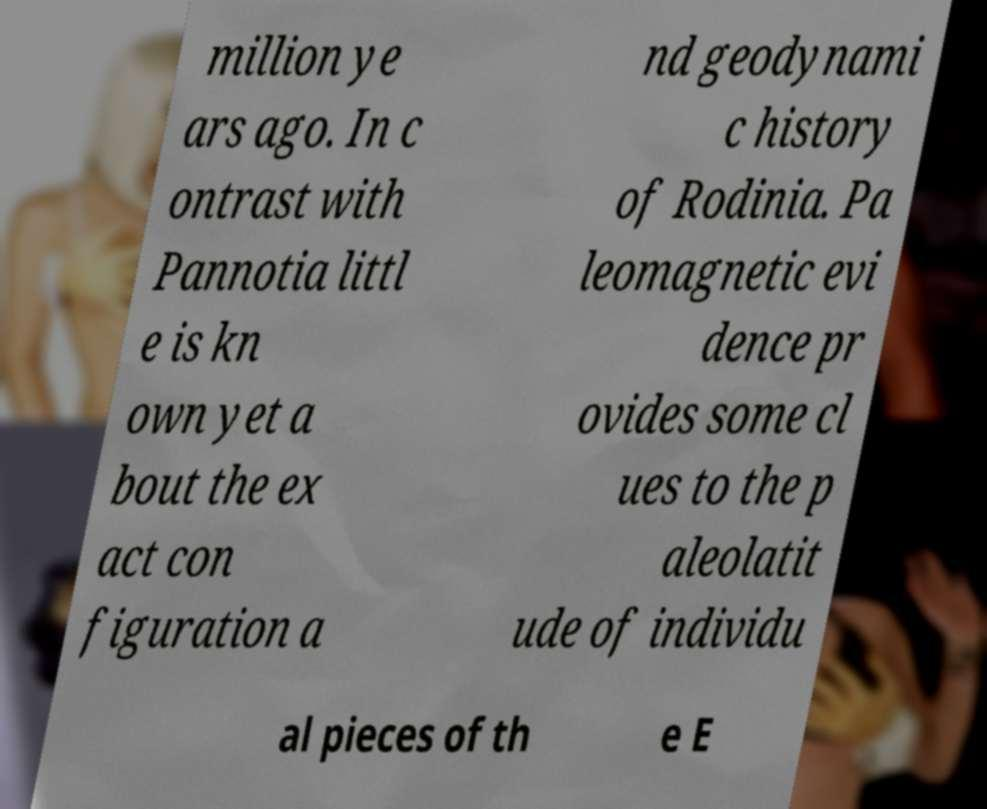Please read and relay the text visible in this image. What does it say? million ye ars ago. In c ontrast with Pannotia littl e is kn own yet a bout the ex act con figuration a nd geodynami c history of Rodinia. Pa leomagnetic evi dence pr ovides some cl ues to the p aleolatit ude of individu al pieces of th e E 